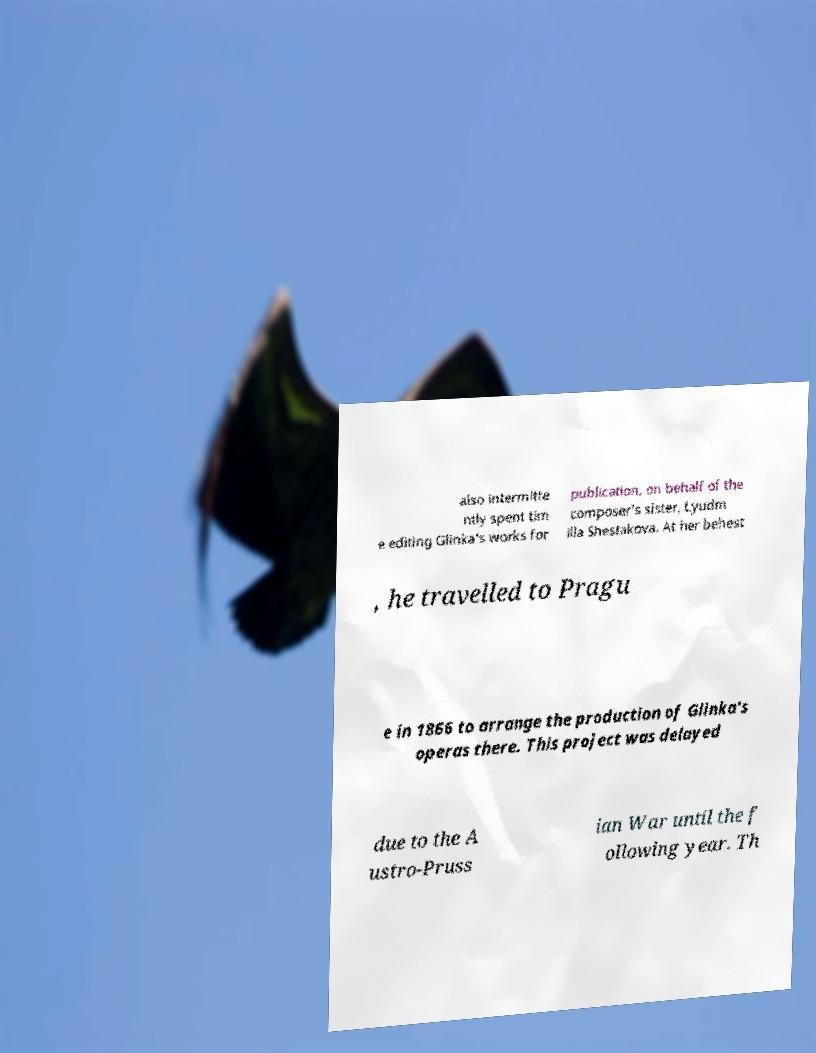Can you accurately transcribe the text from the provided image for me? also intermitte ntly spent tim e editing Glinka's works for publication, on behalf of the composer's sister, Lyudm illa Shestakova. At her behest , he travelled to Pragu e in 1866 to arrange the production of Glinka's operas there. This project was delayed due to the A ustro-Pruss ian War until the f ollowing year. Th 